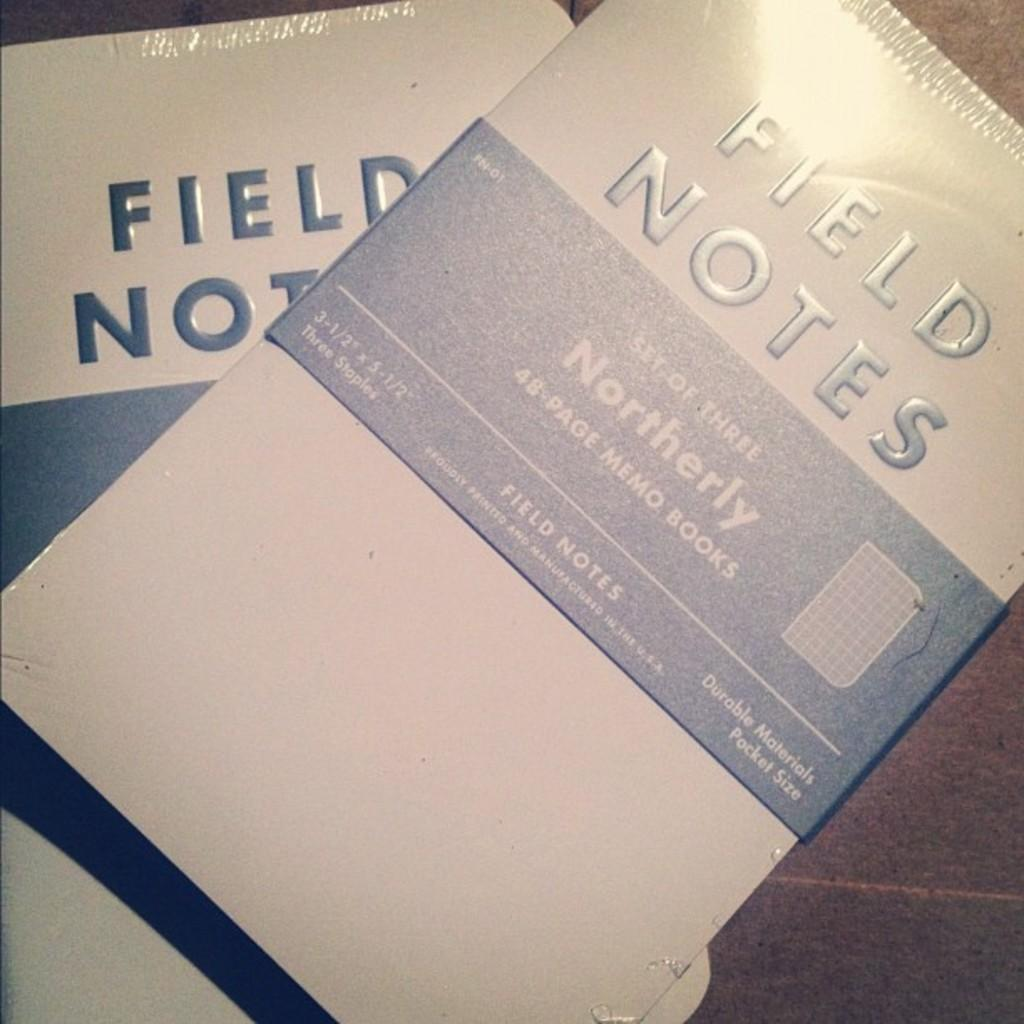<image>
Offer a succinct explanation of the picture presented. A book or notebook with the title FIELD NOTES sits on a table. 